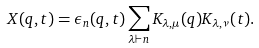<formula> <loc_0><loc_0><loc_500><loc_500>X ( q , t ) = \epsilon _ { n } ( q , t ) \sum _ { \lambda \vdash n } K _ { \lambda , \mu } ( q ) K _ { \lambda , \nu } ( t ) .</formula> 